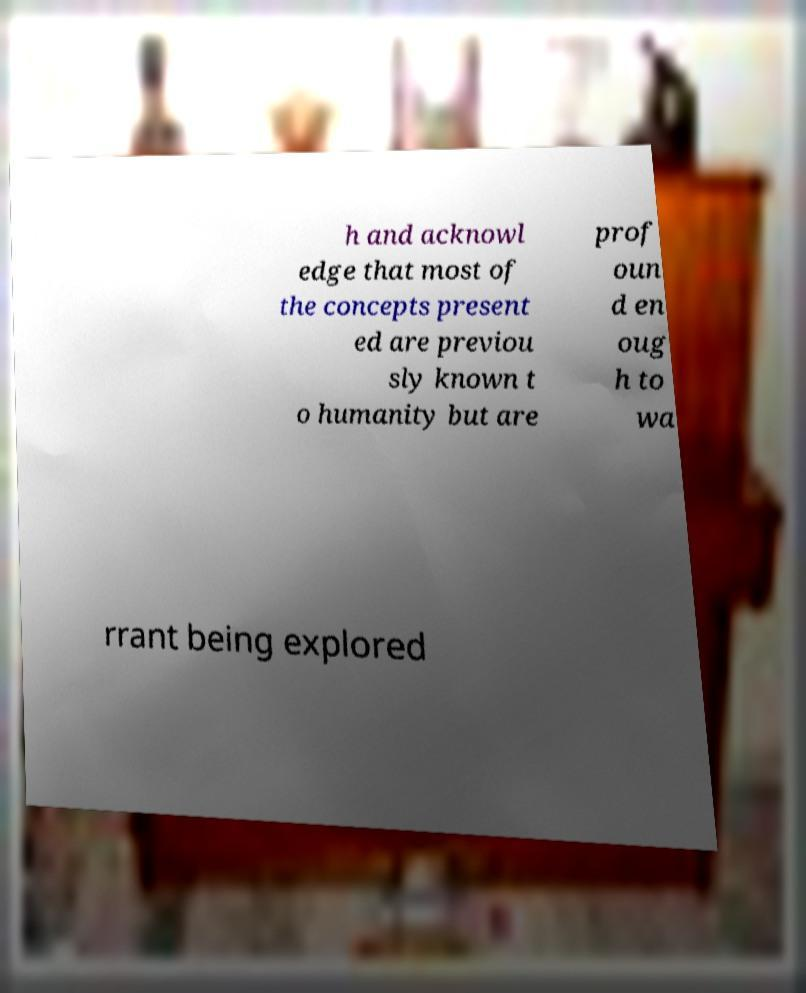Can you read and provide the text displayed in the image?This photo seems to have some interesting text. Can you extract and type it out for me? h and acknowl edge that most of the concepts present ed are previou sly known t o humanity but are prof oun d en oug h to wa rrant being explored 